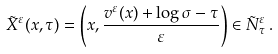<formula> <loc_0><loc_0><loc_500><loc_500>\tilde { X } ^ { \varepsilon } ( x , \tau ) = \left ( x , \frac { v ^ { \varepsilon } ( x ) + \log \sigma - \tau } { \varepsilon } \right ) \in \tilde { N } _ { \tau } ^ { \varepsilon } \, .</formula> 